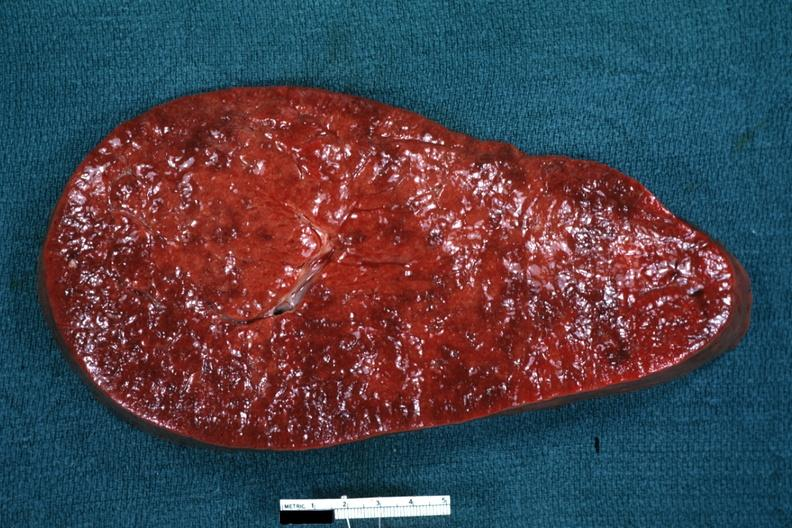s rheumatoid arthritis present?
Answer the question using a single word or phrase. No 